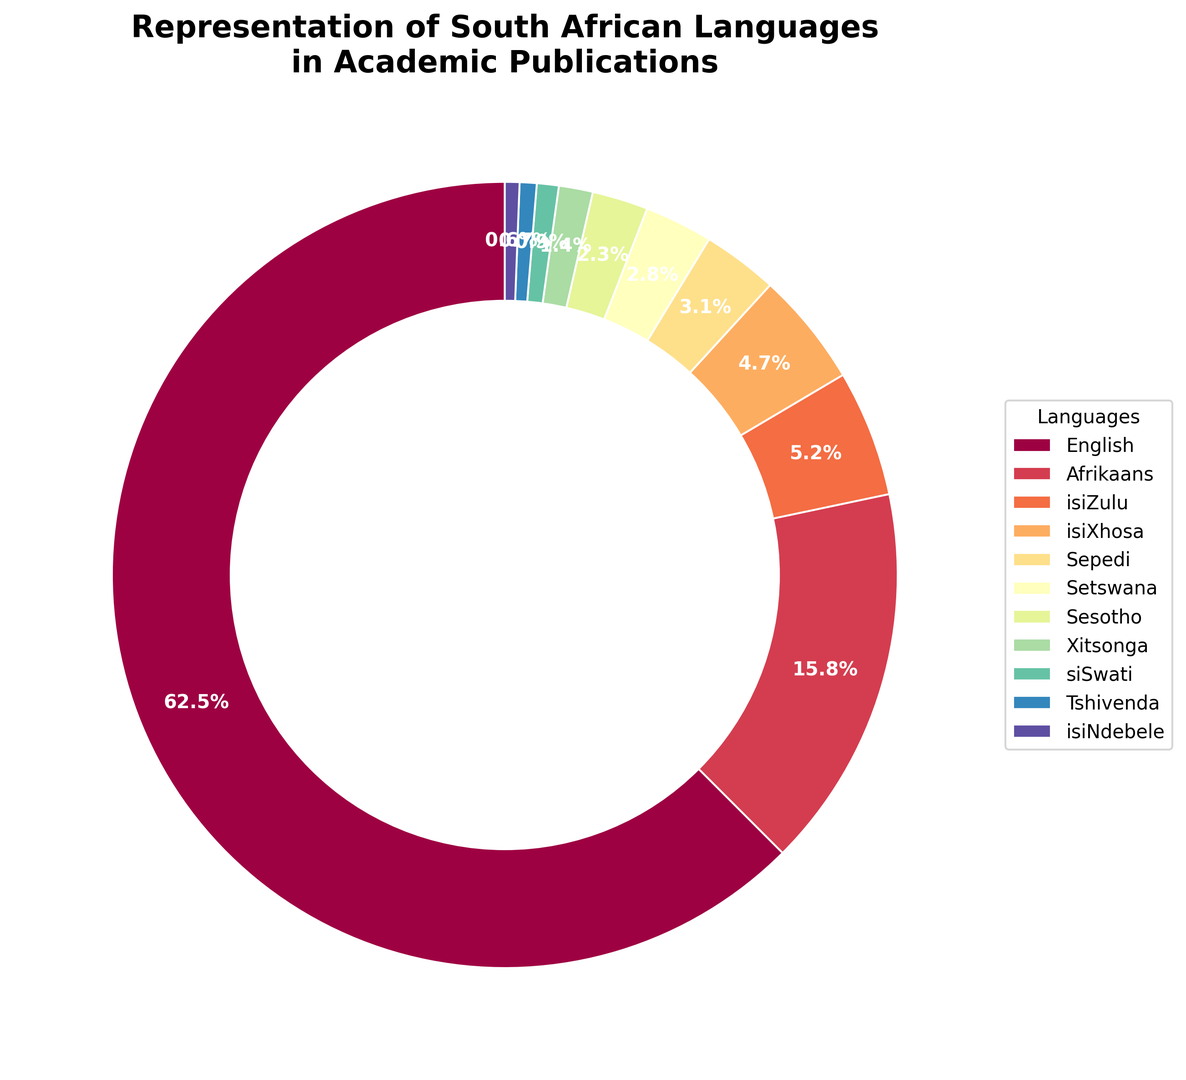What is the percentage representation of English in academic publications? The ring chart shows a section labeled "English" with a percentage indicated. The percentage provided for English is visibly 62.5%.
Answer: 62.5% How do the combined percentages of isiZulu and isiXhosa compare to the percentage of Afrikaans? Locate the percentages for isiZulu (5.2%) and isiXhosa (4.7%) on the chart. Add these two percentages together (5.2% + 4.7% = 9.9%). Then compare this sum to the percentage for Afrikaans (15.8%).
Answer: The combined percentage of isiZulu and isiXhosa (9.9%) is less than that of Afrikaans (15.8%) What is the sum of the percentages for Sepedi, Setswana, and Sesotho? Find the percentages for Sepedi (3.1%), Setswana (2.8%), and Sesotho (2.3%) on the chart. Add these values together: 3.1% + 2.8% + 2.3%.
Answer: 8.2% Which language has the smallest representation in academic publications? Look at the ring chart to identify the smallest segment, and note the language associated with it. The smallest segment corresponds to isiNdebele, which is 0.6%.
Answer: isiNdebele Compare the visual sizes of the sections for Xitsonga and siSwati. Which one is larger? Identify the segments for Xitsonga (1.4%) and siSwati (0.9%) on the chart. Visually compare their sizes. Xitsonga's segment is slightly larger than siSwati's.
Answer: Xitsonga What is the combined percentage of all languages other than English? Calculate the sum of the percentages for all languages except English. (15.8% + 5.2% + 4.7% + 3.1% + 2.8% + 2.3% + 1.4% + 0.9% + 0.7% + 0.6%). The sum is 37.5%.
Answer: 37.5% How many languages have a representation greater than 2%? Identify and count the languages from the chart whose percentage is greater than 2%. These languages are Afrikaans (15.8%), isiZulu (5.2%), isiXhosa (4.7%), Sepedi (3.1%), Setswana (2.8%), and Sesotho (2.3%), making a total of 6 languages.
Answer: 6 Which two languages, other than English, have the highest percentage representation? After English, find the next largest segments on the chart. They correspond to Afrikaans (15.8%) and isiZulu (5.2%).
Answer: Afrikaans and isiZulu What is the percentage difference between Afrikaans and isiXhosa? Subtract the percentage of isiXhosa (4.7%) from the percentage of Afrikaans (15.8%): 15.8% - 4.7%.
Answer: 11.1% Is the representation of isiNdebele higher or lower than that of Tshivenda? Compare the percentages for isiNdebele (0.6%) and Tshivenda (0.7%). isiNdebele's percentage is lower than Tshivenda's.
Answer: Lower 